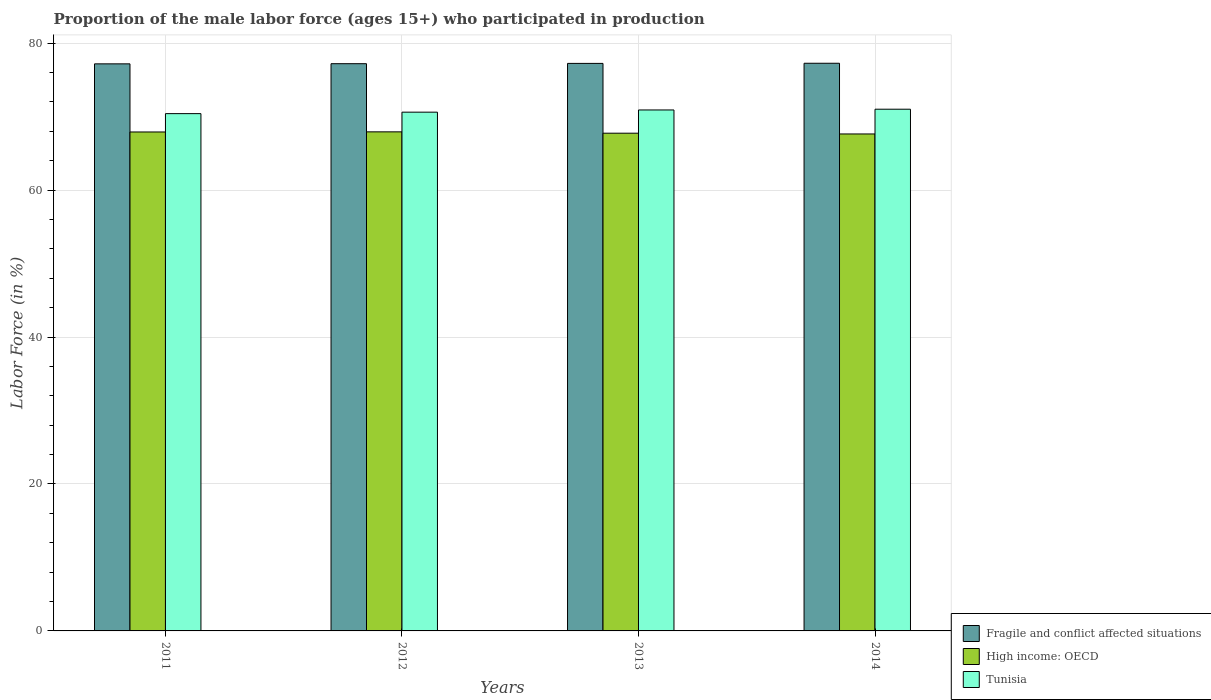How many different coloured bars are there?
Provide a short and direct response. 3. How many groups of bars are there?
Your answer should be compact. 4. How many bars are there on the 3rd tick from the right?
Keep it short and to the point. 3. What is the label of the 4th group of bars from the left?
Offer a very short reply. 2014. What is the proportion of the male labor force who participated in production in Fragile and conflict affected situations in 2014?
Provide a succinct answer. 77.25. Across all years, what is the minimum proportion of the male labor force who participated in production in Tunisia?
Your response must be concise. 70.4. In which year was the proportion of the male labor force who participated in production in Fragile and conflict affected situations maximum?
Ensure brevity in your answer.  2014. In which year was the proportion of the male labor force who participated in production in Fragile and conflict affected situations minimum?
Your response must be concise. 2011. What is the total proportion of the male labor force who participated in production in Fragile and conflict affected situations in the graph?
Provide a short and direct response. 308.86. What is the difference between the proportion of the male labor force who participated in production in Tunisia in 2012 and that in 2014?
Offer a very short reply. -0.4. What is the difference between the proportion of the male labor force who participated in production in Tunisia in 2011 and the proportion of the male labor force who participated in production in High income: OECD in 2013?
Keep it short and to the point. 2.66. What is the average proportion of the male labor force who participated in production in Fragile and conflict affected situations per year?
Offer a very short reply. 77.22. In the year 2011, what is the difference between the proportion of the male labor force who participated in production in High income: OECD and proportion of the male labor force who participated in production in Fragile and conflict affected situations?
Ensure brevity in your answer.  -9.27. What is the ratio of the proportion of the male labor force who participated in production in Tunisia in 2011 to that in 2012?
Provide a short and direct response. 1. Is the proportion of the male labor force who participated in production in High income: OECD in 2011 less than that in 2014?
Provide a short and direct response. No. Is the difference between the proportion of the male labor force who participated in production in High income: OECD in 2011 and 2013 greater than the difference between the proportion of the male labor force who participated in production in Fragile and conflict affected situations in 2011 and 2013?
Your response must be concise. Yes. What is the difference between the highest and the second highest proportion of the male labor force who participated in production in Tunisia?
Give a very brief answer. 0.1. What is the difference between the highest and the lowest proportion of the male labor force who participated in production in High income: OECD?
Make the answer very short. 0.29. In how many years, is the proportion of the male labor force who participated in production in High income: OECD greater than the average proportion of the male labor force who participated in production in High income: OECD taken over all years?
Your response must be concise. 2. Is the sum of the proportion of the male labor force who participated in production in Tunisia in 2011 and 2014 greater than the maximum proportion of the male labor force who participated in production in High income: OECD across all years?
Offer a very short reply. Yes. What does the 1st bar from the left in 2013 represents?
Offer a terse response. Fragile and conflict affected situations. What does the 2nd bar from the right in 2013 represents?
Offer a very short reply. High income: OECD. Is it the case that in every year, the sum of the proportion of the male labor force who participated in production in Tunisia and proportion of the male labor force who participated in production in Fragile and conflict affected situations is greater than the proportion of the male labor force who participated in production in High income: OECD?
Offer a very short reply. Yes. Are all the bars in the graph horizontal?
Provide a short and direct response. No. What is the difference between two consecutive major ticks on the Y-axis?
Ensure brevity in your answer.  20. Where does the legend appear in the graph?
Make the answer very short. Bottom right. How many legend labels are there?
Keep it short and to the point. 3. How are the legend labels stacked?
Make the answer very short. Vertical. What is the title of the graph?
Your answer should be very brief. Proportion of the male labor force (ages 15+) who participated in production. What is the label or title of the Y-axis?
Provide a succinct answer. Labor Force (in %). What is the Labor Force (in %) in Fragile and conflict affected situations in 2011?
Provide a succinct answer. 77.17. What is the Labor Force (in %) in High income: OECD in 2011?
Provide a short and direct response. 67.9. What is the Labor Force (in %) of Tunisia in 2011?
Offer a very short reply. 70.4. What is the Labor Force (in %) in Fragile and conflict affected situations in 2012?
Offer a very short reply. 77.2. What is the Labor Force (in %) of High income: OECD in 2012?
Give a very brief answer. 67.92. What is the Labor Force (in %) of Tunisia in 2012?
Keep it short and to the point. 70.6. What is the Labor Force (in %) in Fragile and conflict affected situations in 2013?
Ensure brevity in your answer.  77.24. What is the Labor Force (in %) of High income: OECD in 2013?
Give a very brief answer. 67.74. What is the Labor Force (in %) of Tunisia in 2013?
Provide a succinct answer. 70.9. What is the Labor Force (in %) in Fragile and conflict affected situations in 2014?
Offer a terse response. 77.25. What is the Labor Force (in %) in High income: OECD in 2014?
Keep it short and to the point. 67.63. What is the Labor Force (in %) of Tunisia in 2014?
Your answer should be compact. 71. Across all years, what is the maximum Labor Force (in %) in Fragile and conflict affected situations?
Your answer should be compact. 77.25. Across all years, what is the maximum Labor Force (in %) of High income: OECD?
Give a very brief answer. 67.92. Across all years, what is the maximum Labor Force (in %) in Tunisia?
Give a very brief answer. 71. Across all years, what is the minimum Labor Force (in %) in Fragile and conflict affected situations?
Ensure brevity in your answer.  77.17. Across all years, what is the minimum Labor Force (in %) in High income: OECD?
Offer a terse response. 67.63. Across all years, what is the minimum Labor Force (in %) of Tunisia?
Ensure brevity in your answer.  70.4. What is the total Labor Force (in %) in Fragile and conflict affected situations in the graph?
Your response must be concise. 308.86. What is the total Labor Force (in %) in High income: OECD in the graph?
Your answer should be compact. 271.19. What is the total Labor Force (in %) in Tunisia in the graph?
Your response must be concise. 282.9. What is the difference between the Labor Force (in %) in Fragile and conflict affected situations in 2011 and that in 2012?
Provide a succinct answer. -0.02. What is the difference between the Labor Force (in %) of High income: OECD in 2011 and that in 2012?
Offer a very short reply. -0.01. What is the difference between the Labor Force (in %) of Fragile and conflict affected situations in 2011 and that in 2013?
Ensure brevity in your answer.  -0.06. What is the difference between the Labor Force (in %) in High income: OECD in 2011 and that in 2013?
Keep it short and to the point. 0.17. What is the difference between the Labor Force (in %) in Tunisia in 2011 and that in 2013?
Your answer should be very brief. -0.5. What is the difference between the Labor Force (in %) of Fragile and conflict affected situations in 2011 and that in 2014?
Your response must be concise. -0.08. What is the difference between the Labor Force (in %) of High income: OECD in 2011 and that in 2014?
Give a very brief answer. 0.27. What is the difference between the Labor Force (in %) of Fragile and conflict affected situations in 2012 and that in 2013?
Make the answer very short. -0.04. What is the difference between the Labor Force (in %) in High income: OECD in 2012 and that in 2013?
Provide a succinct answer. 0.18. What is the difference between the Labor Force (in %) of Fragile and conflict affected situations in 2012 and that in 2014?
Provide a short and direct response. -0.06. What is the difference between the Labor Force (in %) of High income: OECD in 2012 and that in 2014?
Ensure brevity in your answer.  0.29. What is the difference between the Labor Force (in %) of Tunisia in 2012 and that in 2014?
Keep it short and to the point. -0.4. What is the difference between the Labor Force (in %) of Fragile and conflict affected situations in 2013 and that in 2014?
Provide a short and direct response. -0.02. What is the difference between the Labor Force (in %) of High income: OECD in 2013 and that in 2014?
Make the answer very short. 0.1. What is the difference between the Labor Force (in %) of Fragile and conflict affected situations in 2011 and the Labor Force (in %) of High income: OECD in 2012?
Give a very brief answer. 9.26. What is the difference between the Labor Force (in %) of Fragile and conflict affected situations in 2011 and the Labor Force (in %) of Tunisia in 2012?
Make the answer very short. 6.57. What is the difference between the Labor Force (in %) of High income: OECD in 2011 and the Labor Force (in %) of Tunisia in 2012?
Provide a short and direct response. -2.7. What is the difference between the Labor Force (in %) in Fragile and conflict affected situations in 2011 and the Labor Force (in %) in High income: OECD in 2013?
Your answer should be compact. 9.44. What is the difference between the Labor Force (in %) of Fragile and conflict affected situations in 2011 and the Labor Force (in %) of Tunisia in 2013?
Your response must be concise. 6.27. What is the difference between the Labor Force (in %) of High income: OECD in 2011 and the Labor Force (in %) of Tunisia in 2013?
Offer a terse response. -3. What is the difference between the Labor Force (in %) of Fragile and conflict affected situations in 2011 and the Labor Force (in %) of High income: OECD in 2014?
Offer a terse response. 9.54. What is the difference between the Labor Force (in %) in Fragile and conflict affected situations in 2011 and the Labor Force (in %) in Tunisia in 2014?
Ensure brevity in your answer.  6.17. What is the difference between the Labor Force (in %) in High income: OECD in 2011 and the Labor Force (in %) in Tunisia in 2014?
Make the answer very short. -3.1. What is the difference between the Labor Force (in %) in Fragile and conflict affected situations in 2012 and the Labor Force (in %) in High income: OECD in 2013?
Ensure brevity in your answer.  9.46. What is the difference between the Labor Force (in %) in Fragile and conflict affected situations in 2012 and the Labor Force (in %) in Tunisia in 2013?
Offer a terse response. 6.3. What is the difference between the Labor Force (in %) of High income: OECD in 2012 and the Labor Force (in %) of Tunisia in 2013?
Give a very brief answer. -2.98. What is the difference between the Labor Force (in %) in Fragile and conflict affected situations in 2012 and the Labor Force (in %) in High income: OECD in 2014?
Your answer should be compact. 9.56. What is the difference between the Labor Force (in %) in Fragile and conflict affected situations in 2012 and the Labor Force (in %) in Tunisia in 2014?
Offer a terse response. 6.2. What is the difference between the Labor Force (in %) in High income: OECD in 2012 and the Labor Force (in %) in Tunisia in 2014?
Make the answer very short. -3.08. What is the difference between the Labor Force (in %) in Fragile and conflict affected situations in 2013 and the Labor Force (in %) in High income: OECD in 2014?
Ensure brevity in your answer.  9.6. What is the difference between the Labor Force (in %) in Fragile and conflict affected situations in 2013 and the Labor Force (in %) in Tunisia in 2014?
Your response must be concise. 6.24. What is the difference between the Labor Force (in %) of High income: OECD in 2013 and the Labor Force (in %) of Tunisia in 2014?
Offer a terse response. -3.26. What is the average Labor Force (in %) in Fragile and conflict affected situations per year?
Keep it short and to the point. 77.22. What is the average Labor Force (in %) of High income: OECD per year?
Provide a succinct answer. 67.8. What is the average Labor Force (in %) of Tunisia per year?
Provide a succinct answer. 70.72. In the year 2011, what is the difference between the Labor Force (in %) of Fragile and conflict affected situations and Labor Force (in %) of High income: OECD?
Your answer should be very brief. 9.27. In the year 2011, what is the difference between the Labor Force (in %) of Fragile and conflict affected situations and Labor Force (in %) of Tunisia?
Make the answer very short. 6.77. In the year 2011, what is the difference between the Labor Force (in %) in High income: OECD and Labor Force (in %) in Tunisia?
Offer a terse response. -2.5. In the year 2012, what is the difference between the Labor Force (in %) of Fragile and conflict affected situations and Labor Force (in %) of High income: OECD?
Your answer should be compact. 9.28. In the year 2012, what is the difference between the Labor Force (in %) in Fragile and conflict affected situations and Labor Force (in %) in Tunisia?
Give a very brief answer. 6.6. In the year 2012, what is the difference between the Labor Force (in %) in High income: OECD and Labor Force (in %) in Tunisia?
Make the answer very short. -2.68. In the year 2013, what is the difference between the Labor Force (in %) of Fragile and conflict affected situations and Labor Force (in %) of High income: OECD?
Ensure brevity in your answer.  9.5. In the year 2013, what is the difference between the Labor Force (in %) in Fragile and conflict affected situations and Labor Force (in %) in Tunisia?
Provide a succinct answer. 6.34. In the year 2013, what is the difference between the Labor Force (in %) of High income: OECD and Labor Force (in %) of Tunisia?
Your answer should be compact. -3.16. In the year 2014, what is the difference between the Labor Force (in %) of Fragile and conflict affected situations and Labor Force (in %) of High income: OECD?
Your response must be concise. 9.62. In the year 2014, what is the difference between the Labor Force (in %) of Fragile and conflict affected situations and Labor Force (in %) of Tunisia?
Provide a succinct answer. 6.25. In the year 2014, what is the difference between the Labor Force (in %) in High income: OECD and Labor Force (in %) in Tunisia?
Your response must be concise. -3.37. What is the ratio of the Labor Force (in %) in Fragile and conflict affected situations in 2011 to that in 2012?
Your answer should be very brief. 1. What is the ratio of the Labor Force (in %) of Fragile and conflict affected situations in 2011 to that in 2013?
Offer a very short reply. 1. What is the ratio of the Labor Force (in %) in Fragile and conflict affected situations in 2011 to that in 2014?
Ensure brevity in your answer.  1. What is the ratio of the Labor Force (in %) of High income: OECD in 2012 to that in 2013?
Ensure brevity in your answer.  1. What is the ratio of the Labor Force (in %) of Tunisia in 2012 to that in 2013?
Ensure brevity in your answer.  1. What is the ratio of the Labor Force (in %) of Fragile and conflict affected situations in 2012 to that in 2014?
Your response must be concise. 1. What is the ratio of the Labor Force (in %) of Fragile and conflict affected situations in 2013 to that in 2014?
Make the answer very short. 1. What is the ratio of the Labor Force (in %) of Tunisia in 2013 to that in 2014?
Provide a succinct answer. 1. What is the difference between the highest and the second highest Labor Force (in %) in Fragile and conflict affected situations?
Give a very brief answer. 0.02. What is the difference between the highest and the second highest Labor Force (in %) in High income: OECD?
Provide a succinct answer. 0.01. What is the difference between the highest and the lowest Labor Force (in %) of Fragile and conflict affected situations?
Provide a short and direct response. 0.08. What is the difference between the highest and the lowest Labor Force (in %) in High income: OECD?
Provide a succinct answer. 0.29. 